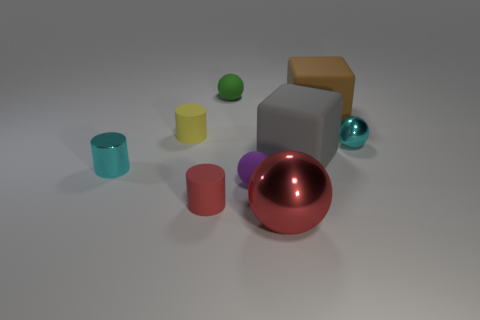What can you tell me about the lighting in the scene? The lighting in the scene appears to be diffused, providing a soft illumination that creates gentle shadows and soft reflections on the objects, especially noticeable on the shiny surfaces like the large ball and the cyan cylinder. How does the lighting affect the colors of the objects? The diffused lighting tends to mute the colors slightly, giving them a soft glow rather than a vivid shine. It also enhances the perception of the textures, making the shiny objects more reflective and the matte objects absorbing the light, hence not reflecting much light. 